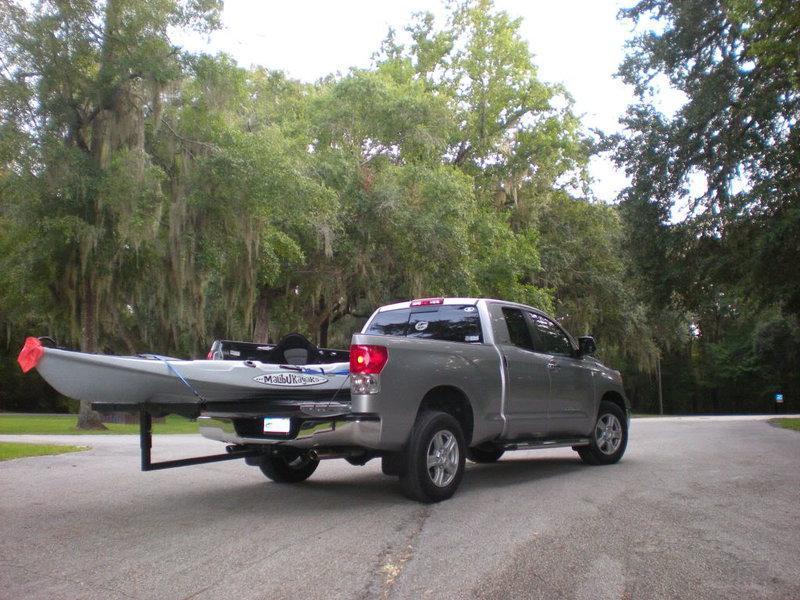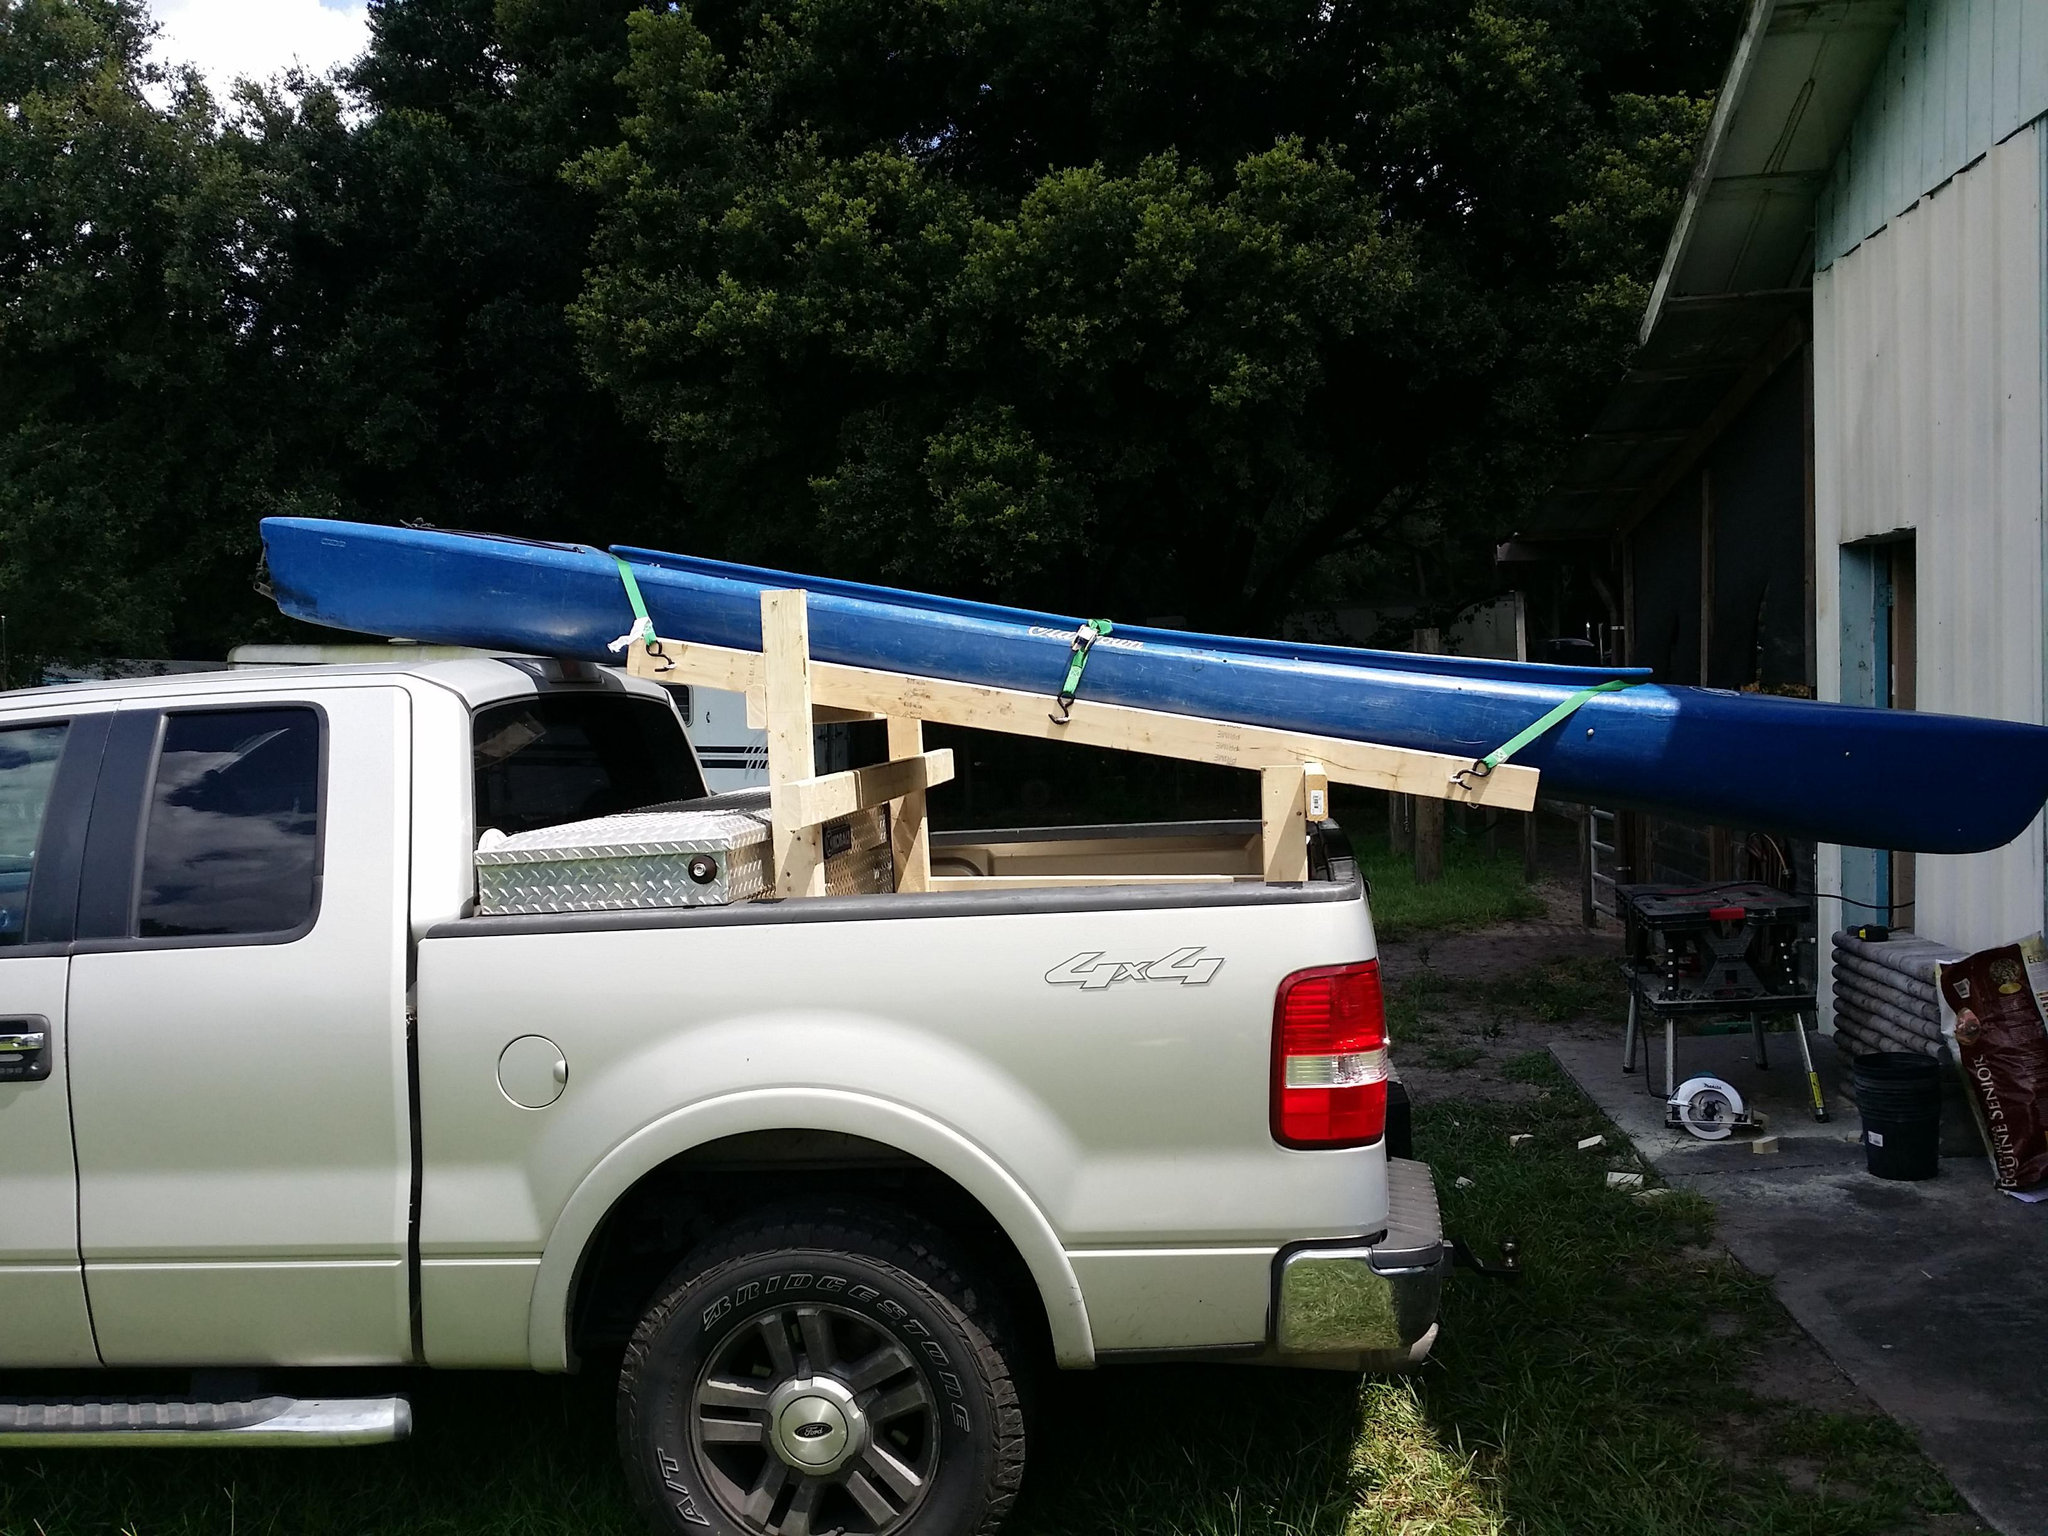The first image is the image on the left, the second image is the image on the right. Assess this claim about the two images: "One of the boats is green.". Correct or not? Answer yes or no. No. 